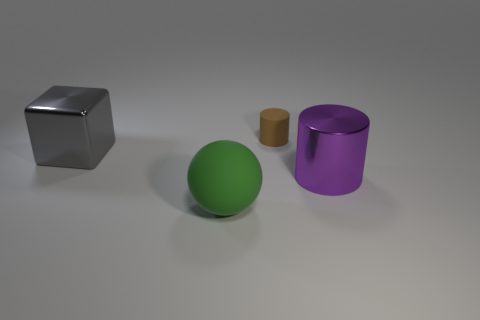There is a cylinder behind the large gray metallic block; what is its material?
Give a very brief answer. Rubber. Do the tiny cylinder and the big object that is behind the metallic cylinder have the same material?
Your answer should be very brief. No. What material is the large object right of the matte ball in front of the metal cube made of?
Ensure brevity in your answer.  Metal. Is the number of big gray metallic objects behind the green object greater than the number of big blue shiny balls?
Your answer should be very brief. Yes. Are there any yellow spheres?
Ensure brevity in your answer.  No. There is a shiny object in front of the large cube; what is its color?
Ensure brevity in your answer.  Purple. There is a purple thing that is the same size as the metal block; what material is it?
Your response must be concise. Metal. How many other objects are the same material as the big sphere?
Ensure brevity in your answer.  1. What color is the thing that is both in front of the tiny brown rubber thing and behind the big purple thing?
Give a very brief answer. Gray. What number of things are either things that are behind the shiny cube or cyan spheres?
Offer a very short reply. 1. 